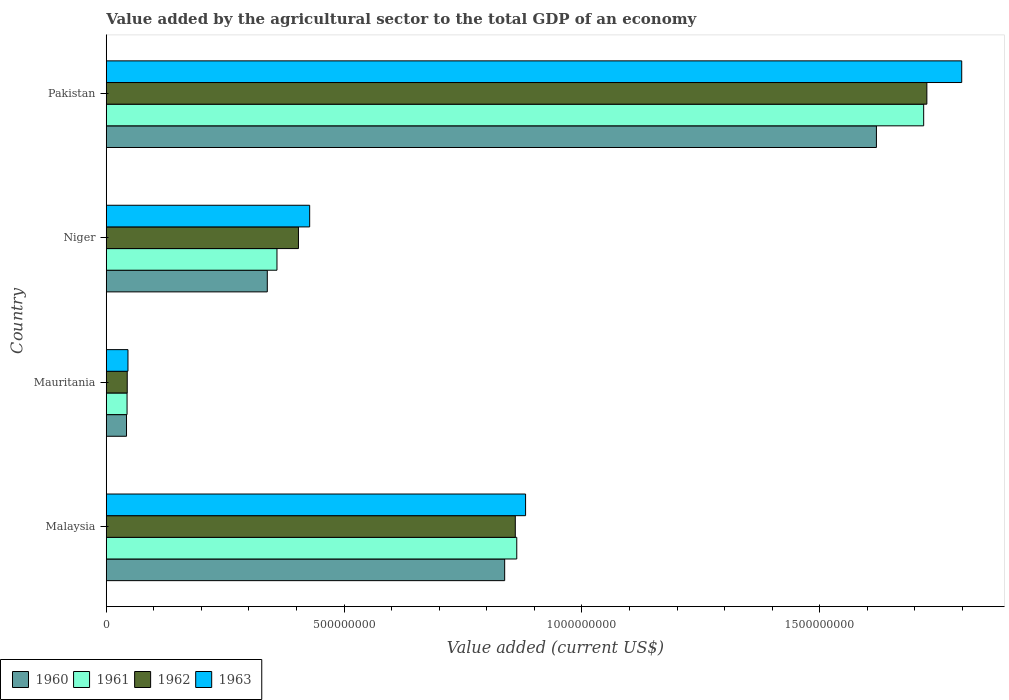How many different coloured bars are there?
Offer a very short reply. 4. How many groups of bars are there?
Your answer should be compact. 4. How many bars are there on the 3rd tick from the top?
Your answer should be very brief. 4. How many bars are there on the 1st tick from the bottom?
Offer a terse response. 4. What is the label of the 2nd group of bars from the top?
Offer a terse response. Niger. In how many cases, is the number of bars for a given country not equal to the number of legend labels?
Provide a short and direct response. 0. What is the value added by the agricultural sector to the total GDP in 1960 in Pakistan?
Offer a terse response. 1.62e+09. Across all countries, what is the maximum value added by the agricultural sector to the total GDP in 1960?
Make the answer very short. 1.62e+09. Across all countries, what is the minimum value added by the agricultural sector to the total GDP in 1963?
Your answer should be very brief. 4.57e+07. In which country was the value added by the agricultural sector to the total GDP in 1962 maximum?
Make the answer very short. Pakistan. In which country was the value added by the agricultural sector to the total GDP in 1961 minimum?
Make the answer very short. Mauritania. What is the total value added by the agricultural sector to the total GDP in 1963 in the graph?
Provide a succinct answer. 3.15e+09. What is the difference between the value added by the agricultural sector to the total GDP in 1962 in Mauritania and that in Pakistan?
Provide a succinct answer. -1.68e+09. What is the difference between the value added by the agricultural sector to the total GDP in 1963 in Malaysia and the value added by the agricultural sector to the total GDP in 1961 in Pakistan?
Your response must be concise. -8.37e+08. What is the average value added by the agricultural sector to the total GDP in 1962 per country?
Provide a short and direct response. 7.58e+08. What is the difference between the value added by the agricultural sector to the total GDP in 1960 and value added by the agricultural sector to the total GDP in 1962 in Malaysia?
Provide a succinct answer. -2.23e+07. What is the ratio of the value added by the agricultural sector to the total GDP in 1963 in Mauritania to that in Niger?
Provide a short and direct response. 0.11. Is the value added by the agricultural sector to the total GDP in 1960 in Niger less than that in Pakistan?
Offer a terse response. Yes. What is the difference between the highest and the second highest value added by the agricultural sector to the total GDP in 1960?
Offer a terse response. 7.82e+08. What is the difference between the highest and the lowest value added by the agricultural sector to the total GDP in 1963?
Your answer should be very brief. 1.75e+09. In how many countries, is the value added by the agricultural sector to the total GDP in 1963 greater than the average value added by the agricultural sector to the total GDP in 1963 taken over all countries?
Provide a succinct answer. 2. Is it the case that in every country, the sum of the value added by the agricultural sector to the total GDP in 1962 and value added by the agricultural sector to the total GDP in 1963 is greater than the sum of value added by the agricultural sector to the total GDP in 1961 and value added by the agricultural sector to the total GDP in 1960?
Offer a terse response. No. What does the 4th bar from the top in Mauritania represents?
Your answer should be very brief. 1960. Is it the case that in every country, the sum of the value added by the agricultural sector to the total GDP in 1961 and value added by the agricultural sector to the total GDP in 1963 is greater than the value added by the agricultural sector to the total GDP in 1962?
Provide a succinct answer. Yes. What is the difference between two consecutive major ticks on the X-axis?
Offer a terse response. 5.00e+08. Are the values on the major ticks of X-axis written in scientific E-notation?
Provide a short and direct response. No. Does the graph contain grids?
Provide a short and direct response. No. Where does the legend appear in the graph?
Provide a succinct answer. Bottom left. How many legend labels are there?
Give a very brief answer. 4. What is the title of the graph?
Provide a short and direct response. Value added by the agricultural sector to the total GDP of an economy. What is the label or title of the X-axis?
Your answer should be compact. Value added (current US$). What is the label or title of the Y-axis?
Offer a very short reply. Country. What is the Value added (current US$) of 1960 in Malaysia?
Offer a terse response. 8.38e+08. What is the Value added (current US$) in 1961 in Malaysia?
Offer a terse response. 8.63e+08. What is the Value added (current US$) of 1962 in Malaysia?
Your answer should be compact. 8.60e+08. What is the Value added (current US$) in 1963 in Malaysia?
Make the answer very short. 8.82e+08. What is the Value added (current US$) of 1960 in Mauritania?
Your answer should be very brief. 4.26e+07. What is the Value added (current US$) in 1961 in Mauritania?
Keep it short and to the point. 4.37e+07. What is the Value added (current US$) of 1962 in Mauritania?
Make the answer very short. 4.41e+07. What is the Value added (current US$) of 1963 in Mauritania?
Your answer should be compact. 4.57e+07. What is the Value added (current US$) in 1960 in Niger?
Offer a terse response. 3.39e+08. What is the Value added (current US$) in 1961 in Niger?
Offer a terse response. 3.59e+08. What is the Value added (current US$) of 1962 in Niger?
Your answer should be very brief. 4.04e+08. What is the Value added (current US$) in 1963 in Niger?
Give a very brief answer. 4.28e+08. What is the Value added (current US$) in 1960 in Pakistan?
Provide a succinct answer. 1.62e+09. What is the Value added (current US$) of 1961 in Pakistan?
Keep it short and to the point. 1.72e+09. What is the Value added (current US$) of 1962 in Pakistan?
Provide a short and direct response. 1.73e+09. What is the Value added (current US$) in 1963 in Pakistan?
Give a very brief answer. 1.80e+09. Across all countries, what is the maximum Value added (current US$) in 1960?
Offer a terse response. 1.62e+09. Across all countries, what is the maximum Value added (current US$) of 1961?
Offer a very short reply. 1.72e+09. Across all countries, what is the maximum Value added (current US$) of 1962?
Give a very brief answer. 1.73e+09. Across all countries, what is the maximum Value added (current US$) in 1963?
Provide a succinct answer. 1.80e+09. Across all countries, what is the minimum Value added (current US$) in 1960?
Provide a succinct answer. 4.26e+07. Across all countries, what is the minimum Value added (current US$) in 1961?
Offer a terse response. 4.37e+07. Across all countries, what is the minimum Value added (current US$) in 1962?
Provide a succinct answer. 4.41e+07. Across all countries, what is the minimum Value added (current US$) of 1963?
Offer a terse response. 4.57e+07. What is the total Value added (current US$) of 1960 in the graph?
Give a very brief answer. 2.84e+09. What is the total Value added (current US$) in 1961 in the graph?
Offer a very short reply. 2.98e+09. What is the total Value added (current US$) in 1962 in the graph?
Keep it short and to the point. 3.03e+09. What is the total Value added (current US$) of 1963 in the graph?
Your response must be concise. 3.15e+09. What is the difference between the Value added (current US$) in 1960 in Malaysia and that in Mauritania?
Provide a short and direct response. 7.95e+08. What is the difference between the Value added (current US$) of 1961 in Malaysia and that in Mauritania?
Make the answer very short. 8.19e+08. What is the difference between the Value added (current US$) in 1962 in Malaysia and that in Mauritania?
Your answer should be very brief. 8.16e+08. What is the difference between the Value added (current US$) of 1963 in Malaysia and that in Mauritania?
Your response must be concise. 8.36e+08. What is the difference between the Value added (current US$) in 1960 in Malaysia and that in Niger?
Keep it short and to the point. 4.99e+08. What is the difference between the Value added (current US$) of 1961 in Malaysia and that in Niger?
Keep it short and to the point. 5.04e+08. What is the difference between the Value added (current US$) of 1962 in Malaysia and that in Niger?
Your response must be concise. 4.56e+08. What is the difference between the Value added (current US$) in 1963 in Malaysia and that in Niger?
Offer a very short reply. 4.54e+08. What is the difference between the Value added (current US$) in 1960 in Malaysia and that in Pakistan?
Your answer should be compact. -7.82e+08. What is the difference between the Value added (current US$) in 1961 in Malaysia and that in Pakistan?
Provide a short and direct response. -8.56e+08. What is the difference between the Value added (current US$) of 1962 in Malaysia and that in Pakistan?
Keep it short and to the point. -8.65e+08. What is the difference between the Value added (current US$) in 1963 in Malaysia and that in Pakistan?
Your answer should be compact. -9.17e+08. What is the difference between the Value added (current US$) of 1960 in Mauritania and that in Niger?
Give a very brief answer. -2.96e+08. What is the difference between the Value added (current US$) in 1961 in Mauritania and that in Niger?
Your response must be concise. -3.15e+08. What is the difference between the Value added (current US$) of 1962 in Mauritania and that in Niger?
Your answer should be compact. -3.60e+08. What is the difference between the Value added (current US$) in 1963 in Mauritania and that in Niger?
Offer a terse response. -3.82e+08. What is the difference between the Value added (current US$) in 1960 in Mauritania and that in Pakistan?
Provide a short and direct response. -1.58e+09. What is the difference between the Value added (current US$) in 1961 in Mauritania and that in Pakistan?
Make the answer very short. -1.67e+09. What is the difference between the Value added (current US$) in 1962 in Mauritania and that in Pakistan?
Your answer should be compact. -1.68e+09. What is the difference between the Value added (current US$) of 1963 in Mauritania and that in Pakistan?
Your answer should be very brief. -1.75e+09. What is the difference between the Value added (current US$) of 1960 in Niger and that in Pakistan?
Ensure brevity in your answer.  -1.28e+09. What is the difference between the Value added (current US$) of 1961 in Niger and that in Pakistan?
Give a very brief answer. -1.36e+09. What is the difference between the Value added (current US$) of 1962 in Niger and that in Pakistan?
Provide a succinct answer. -1.32e+09. What is the difference between the Value added (current US$) in 1963 in Niger and that in Pakistan?
Your answer should be compact. -1.37e+09. What is the difference between the Value added (current US$) in 1960 in Malaysia and the Value added (current US$) in 1961 in Mauritania?
Your response must be concise. 7.94e+08. What is the difference between the Value added (current US$) of 1960 in Malaysia and the Value added (current US$) of 1962 in Mauritania?
Give a very brief answer. 7.94e+08. What is the difference between the Value added (current US$) in 1960 in Malaysia and the Value added (current US$) in 1963 in Mauritania?
Your response must be concise. 7.92e+08. What is the difference between the Value added (current US$) in 1961 in Malaysia and the Value added (current US$) in 1962 in Mauritania?
Provide a short and direct response. 8.19e+08. What is the difference between the Value added (current US$) of 1961 in Malaysia and the Value added (current US$) of 1963 in Mauritania?
Provide a succinct answer. 8.17e+08. What is the difference between the Value added (current US$) of 1962 in Malaysia and the Value added (current US$) of 1963 in Mauritania?
Keep it short and to the point. 8.14e+08. What is the difference between the Value added (current US$) in 1960 in Malaysia and the Value added (current US$) in 1961 in Niger?
Provide a short and direct response. 4.79e+08. What is the difference between the Value added (current US$) in 1960 in Malaysia and the Value added (current US$) in 1962 in Niger?
Keep it short and to the point. 4.34e+08. What is the difference between the Value added (current US$) in 1960 in Malaysia and the Value added (current US$) in 1963 in Niger?
Provide a short and direct response. 4.10e+08. What is the difference between the Value added (current US$) of 1961 in Malaysia and the Value added (current US$) of 1962 in Niger?
Your answer should be compact. 4.59e+08. What is the difference between the Value added (current US$) in 1961 in Malaysia and the Value added (current US$) in 1963 in Niger?
Your answer should be very brief. 4.35e+08. What is the difference between the Value added (current US$) of 1962 in Malaysia and the Value added (current US$) of 1963 in Niger?
Offer a very short reply. 4.32e+08. What is the difference between the Value added (current US$) in 1960 in Malaysia and the Value added (current US$) in 1961 in Pakistan?
Provide a succinct answer. -8.81e+08. What is the difference between the Value added (current US$) in 1960 in Malaysia and the Value added (current US$) in 1962 in Pakistan?
Your answer should be compact. -8.88e+08. What is the difference between the Value added (current US$) in 1960 in Malaysia and the Value added (current US$) in 1963 in Pakistan?
Offer a very short reply. -9.61e+08. What is the difference between the Value added (current US$) of 1961 in Malaysia and the Value added (current US$) of 1962 in Pakistan?
Offer a very short reply. -8.62e+08. What is the difference between the Value added (current US$) of 1961 in Malaysia and the Value added (current US$) of 1963 in Pakistan?
Offer a very short reply. -9.36e+08. What is the difference between the Value added (current US$) in 1962 in Malaysia and the Value added (current US$) in 1963 in Pakistan?
Offer a very short reply. -9.39e+08. What is the difference between the Value added (current US$) of 1960 in Mauritania and the Value added (current US$) of 1961 in Niger?
Your answer should be very brief. -3.16e+08. What is the difference between the Value added (current US$) in 1960 in Mauritania and the Value added (current US$) in 1962 in Niger?
Offer a terse response. -3.62e+08. What is the difference between the Value added (current US$) in 1960 in Mauritania and the Value added (current US$) in 1963 in Niger?
Offer a terse response. -3.85e+08. What is the difference between the Value added (current US$) in 1961 in Mauritania and the Value added (current US$) in 1962 in Niger?
Give a very brief answer. -3.60e+08. What is the difference between the Value added (current US$) in 1961 in Mauritania and the Value added (current US$) in 1963 in Niger?
Your answer should be compact. -3.84e+08. What is the difference between the Value added (current US$) of 1962 in Mauritania and the Value added (current US$) of 1963 in Niger?
Your response must be concise. -3.84e+08. What is the difference between the Value added (current US$) in 1960 in Mauritania and the Value added (current US$) in 1961 in Pakistan?
Your response must be concise. -1.68e+09. What is the difference between the Value added (current US$) of 1960 in Mauritania and the Value added (current US$) of 1962 in Pakistan?
Ensure brevity in your answer.  -1.68e+09. What is the difference between the Value added (current US$) of 1960 in Mauritania and the Value added (current US$) of 1963 in Pakistan?
Make the answer very short. -1.76e+09. What is the difference between the Value added (current US$) in 1961 in Mauritania and the Value added (current US$) in 1962 in Pakistan?
Provide a succinct answer. -1.68e+09. What is the difference between the Value added (current US$) of 1961 in Mauritania and the Value added (current US$) of 1963 in Pakistan?
Offer a terse response. -1.75e+09. What is the difference between the Value added (current US$) of 1962 in Mauritania and the Value added (current US$) of 1963 in Pakistan?
Offer a terse response. -1.75e+09. What is the difference between the Value added (current US$) in 1960 in Niger and the Value added (current US$) in 1961 in Pakistan?
Offer a terse response. -1.38e+09. What is the difference between the Value added (current US$) of 1960 in Niger and the Value added (current US$) of 1962 in Pakistan?
Your answer should be very brief. -1.39e+09. What is the difference between the Value added (current US$) in 1960 in Niger and the Value added (current US$) in 1963 in Pakistan?
Provide a succinct answer. -1.46e+09. What is the difference between the Value added (current US$) of 1961 in Niger and the Value added (current US$) of 1962 in Pakistan?
Your response must be concise. -1.37e+09. What is the difference between the Value added (current US$) in 1961 in Niger and the Value added (current US$) in 1963 in Pakistan?
Provide a succinct answer. -1.44e+09. What is the difference between the Value added (current US$) in 1962 in Niger and the Value added (current US$) in 1963 in Pakistan?
Your response must be concise. -1.39e+09. What is the average Value added (current US$) of 1960 per country?
Your answer should be very brief. 7.10e+08. What is the average Value added (current US$) in 1961 per country?
Offer a very short reply. 7.46e+08. What is the average Value added (current US$) of 1962 per country?
Ensure brevity in your answer.  7.58e+08. What is the average Value added (current US$) in 1963 per country?
Keep it short and to the point. 7.88e+08. What is the difference between the Value added (current US$) of 1960 and Value added (current US$) of 1961 in Malaysia?
Your answer should be compact. -2.54e+07. What is the difference between the Value added (current US$) of 1960 and Value added (current US$) of 1962 in Malaysia?
Your response must be concise. -2.23e+07. What is the difference between the Value added (current US$) in 1960 and Value added (current US$) in 1963 in Malaysia?
Your answer should be compact. -4.39e+07. What is the difference between the Value added (current US$) of 1961 and Value added (current US$) of 1962 in Malaysia?
Make the answer very short. 3.09e+06. What is the difference between the Value added (current US$) in 1961 and Value added (current US$) in 1963 in Malaysia?
Keep it short and to the point. -1.85e+07. What is the difference between the Value added (current US$) in 1962 and Value added (current US$) in 1963 in Malaysia?
Give a very brief answer. -2.16e+07. What is the difference between the Value added (current US$) in 1960 and Value added (current US$) in 1961 in Mauritania?
Offer a terse response. -1.15e+06. What is the difference between the Value added (current US$) in 1960 and Value added (current US$) in 1962 in Mauritania?
Ensure brevity in your answer.  -1.54e+06. What is the difference between the Value added (current US$) of 1960 and Value added (current US$) of 1963 in Mauritania?
Your answer should be compact. -3.07e+06. What is the difference between the Value added (current US$) in 1961 and Value added (current US$) in 1962 in Mauritania?
Give a very brief answer. -3.84e+05. What is the difference between the Value added (current US$) of 1961 and Value added (current US$) of 1963 in Mauritania?
Offer a terse response. -1.92e+06. What is the difference between the Value added (current US$) of 1962 and Value added (current US$) of 1963 in Mauritania?
Provide a short and direct response. -1.54e+06. What is the difference between the Value added (current US$) in 1960 and Value added (current US$) in 1961 in Niger?
Provide a short and direct response. -2.03e+07. What is the difference between the Value added (current US$) in 1960 and Value added (current US$) in 1962 in Niger?
Your answer should be compact. -6.55e+07. What is the difference between the Value added (current US$) in 1960 and Value added (current US$) in 1963 in Niger?
Offer a terse response. -8.91e+07. What is the difference between the Value added (current US$) in 1961 and Value added (current US$) in 1962 in Niger?
Make the answer very short. -4.52e+07. What is the difference between the Value added (current US$) in 1961 and Value added (current US$) in 1963 in Niger?
Offer a terse response. -6.88e+07. What is the difference between the Value added (current US$) of 1962 and Value added (current US$) of 1963 in Niger?
Give a very brief answer. -2.36e+07. What is the difference between the Value added (current US$) in 1960 and Value added (current US$) in 1961 in Pakistan?
Offer a terse response. -9.93e+07. What is the difference between the Value added (current US$) in 1960 and Value added (current US$) in 1962 in Pakistan?
Make the answer very short. -1.06e+08. What is the difference between the Value added (current US$) in 1960 and Value added (current US$) in 1963 in Pakistan?
Keep it short and to the point. -1.79e+08. What is the difference between the Value added (current US$) of 1961 and Value added (current US$) of 1962 in Pakistan?
Offer a terse response. -6.72e+06. What is the difference between the Value added (current US$) in 1961 and Value added (current US$) in 1963 in Pakistan?
Offer a terse response. -8.00e+07. What is the difference between the Value added (current US$) of 1962 and Value added (current US$) of 1963 in Pakistan?
Provide a succinct answer. -7.33e+07. What is the ratio of the Value added (current US$) of 1960 in Malaysia to that in Mauritania?
Your response must be concise. 19.67. What is the ratio of the Value added (current US$) in 1961 in Malaysia to that in Mauritania?
Your answer should be compact. 19.73. What is the ratio of the Value added (current US$) in 1962 in Malaysia to that in Mauritania?
Offer a very short reply. 19.49. What is the ratio of the Value added (current US$) in 1963 in Malaysia to that in Mauritania?
Give a very brief answer. 19.31. What is the ratio of the Value added (current US$) of 1960 in Malaysia to that in Niger?
Keep it short and to the point. 2.47. What is the ratio of the Value added (current US$) of 1961 in Malaysia to that in Niger?
Offer a terse response. 2.4. What is the ratio of the Value added (current US$) in 1962 in Malaysia to that in Niger?
Offer a very short reply. 2.13. What is the ratio of the Value added (current US$) in 1963 in Malaysia to that in Niger?
Give a very brief answer. 2.06. What is the ratio of the Value added (current US$) of 1960 in Malaysia to that in Pakistan?
Keep it short and to the point. 0.52. What is the ratio of the Value added (current US$) in 1961 in Malaysia to that in Pakistan?
Your response must be concise. 0.5. What is the ratio of the Value added (current US$) of 1962 in Malaysia to that in Pakistan?
Provide a succinct answer. 0.5. What is the ratio of the Value added (current US$) in 1963 in Malaysia to that in Pakistan?
Your answer should be very brief. 0.49. What is the ratio of the Value added (current US$) of 1960 in Mauritania to that in Niger?
Your answer should be very brief. 0.13. What is the ratio of the Value added (current US$) of 1961 in Mauritania to that in Niger?
Your answer should be very brief. 0.12. What is the ratio of the Value added (current US$) of 1962 in Mauritania to that in Niger?
Make the answer very short. 0.11. What is the ratio of the Value added (current US$) of 1963 in Mauritania to that in Niger?
Your answer should be very brief. 0.11. What is the ratio of the Value added (current US$) of 1960 in Mauritania to that in Pakistan?
Offer a terse response. 0.03. What is the ratio of the Value added (current US$) in 1961 in Mauritania to that in Pakistan?
Your answer should be compact. 0.03. What is the ratio of the Value added (current US$) in 1962 in Mauritania to that in Pakistan?
Provide a succinct answer. 0.03. What is the ratio of the Value added (current US$) of 1963 in Mauritania to that in Pakistan?
Offer a terse response. 0.03. What is the ratio of the Value added (current US$) in 1960 in Niger to that in Pakistan?
Give a very brief answer. 0.21. What is the ratio of the Value added (current US$) of 1961 in Niger to that in Pakistan?
Offer a terse response. 0.21. What is the ratio of the Value added (current US$) in 1962 in Niger to that in Pakistan?
Make the answer very short. 0.23. What is the ratio of the Value added (current US$) of 1963 in Niger to that in Pakistan?
Provide a short and direct response. 0.24. What is the difference between the highest and the second highest Value added (current US$) in 1960?
Offer a terse response. 7.82e+08. What is the difference between the highest and the second highest Value added (current US$) in 1961?
Offer a very short reply. 8.56e+08. What is the difference between the highest and the second highest Value added (current US$) of 1962?
Offer a very short reply. 8.65e+08. What is the difference between the highest and the second highest Value added (current US$) in 1963?
Give a very brief answer. 9.17e+08. What is the difference between the highest and the lowest Value added (current US$) of 1960?
Give a very brief answer. 1.58e+09. What is the difference between the highest and the lowest Value added (current US$) in 1961?
Make the answer very short. 1.67e+09. What is the difference between the highest and the lowest Value added (current US$) of 1962?
Provide a succinct answer. 1.68e+09. What is the difference between the highest and the lowest Value added (current US$) of 1963?
Ensure brevity in your answer.  1.75e+09. 